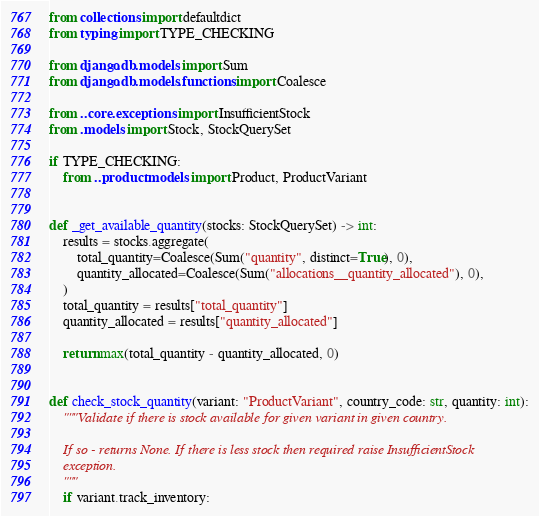<code> <loc_0><loc_0><loc_500><loc_500><_Python_>from collections import defaultdict
from typing import TYPE_CHECKING

from django.db.models import Sum
from django.db.models.functions import Coalesce

from ..core.exceptions import InsufficientStock
from .models import Stock, StockQuerySet

if TYPE_CHECKING:
    from ..product.models import Product, ProductVariant


def _get_available_quantity(stocks: StockQuerySet) -> int:
    results = stocks.aggregate(
        total_quantity=Coalesce(Sum("quantity", distinct=True), 0),
        quantity_allocated=Coalesce(Sum("allocations__quantity_allocated"), 0),
    )
    total_quantity = results["total_quantity"]
    quantity_allocated = results["quantity_allocated"]

    return max(total_quantity - quantity_allocated, 0)


def check_stock_quantity(variant: "ProductVariant", country_code: str, quantity: int):
    """Validate if there is stock available for given variant in given country.

    If so - returns None. If there is less stock then required raise InsufficientStock
    exception.
    """
    if variant.track_inventory:</code> 